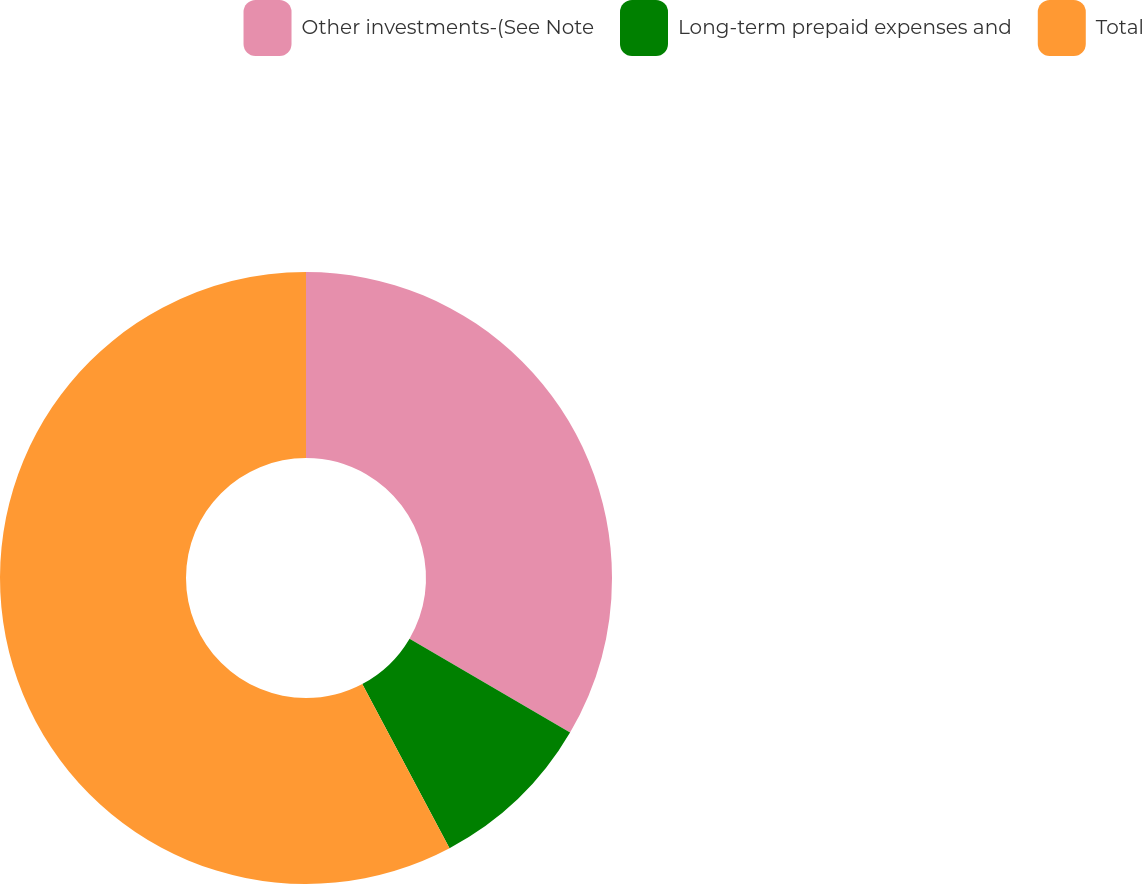<chart> <loc_0><loc_0><loc_500><loc_500><pie_chart><fcel>Other investments-(See Note<fcel>Long-term prepaid expenses and<fcel>Total<nl><fcel>33.43%<fcel>8.8%<fcel>57.77%<nl></chart> 